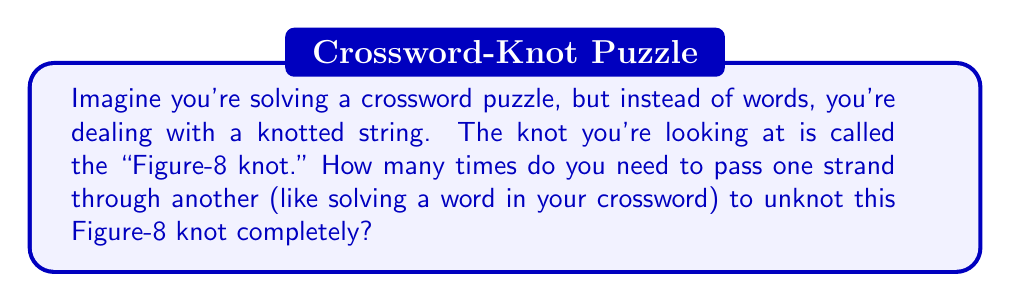Help me with this question. To solve this problem, we need to understand the concept of unknotting number and apply it to the Figure-8 knot. Let's break it down step-by-step:

1. The unknotting number of a knot is the minimum number of times the knot must be passed through itself to untie it completely.

2. For the Figure-8 knot, we can visualize it as follows:
   [asy]
   import geometry;
   
   path p = (0,0)..(1,1)..(2,0)..(1,-1)..cycle;
   path q = (0,0)..(1,-1)..(2,0)..(1,1)..cycle;
   
   draw(p, linewidth(2));
   draw(q, linewidth(2));
   
   dot((0,0));
   dot((2,0));
   dot((1,1));
   dot((1,-1));
   [/asy]

3. The Figure-8 knot has a property called "alternating," which means the crossings alternate between over and under as we trace the knot.

4. For alternating knots, there's a theorem that states: The unknotting number is less than or equal to half the crossing number.

5. The Figure-8 knot has 4 crossings, so its unknotting number is at most 2.

6. However, it can be proven that a single crossing change is not sufficient to unknot the Figure-8 knot.

7. Therefore, the unknotting number of the Figure-8 knot is exactly 2.

This means you need to pass one strand through another exactly twice to completely unknot the Figure-8 knot, similar to solving two crucial words in your crossword puzzle to complete it.
Answer: 2 